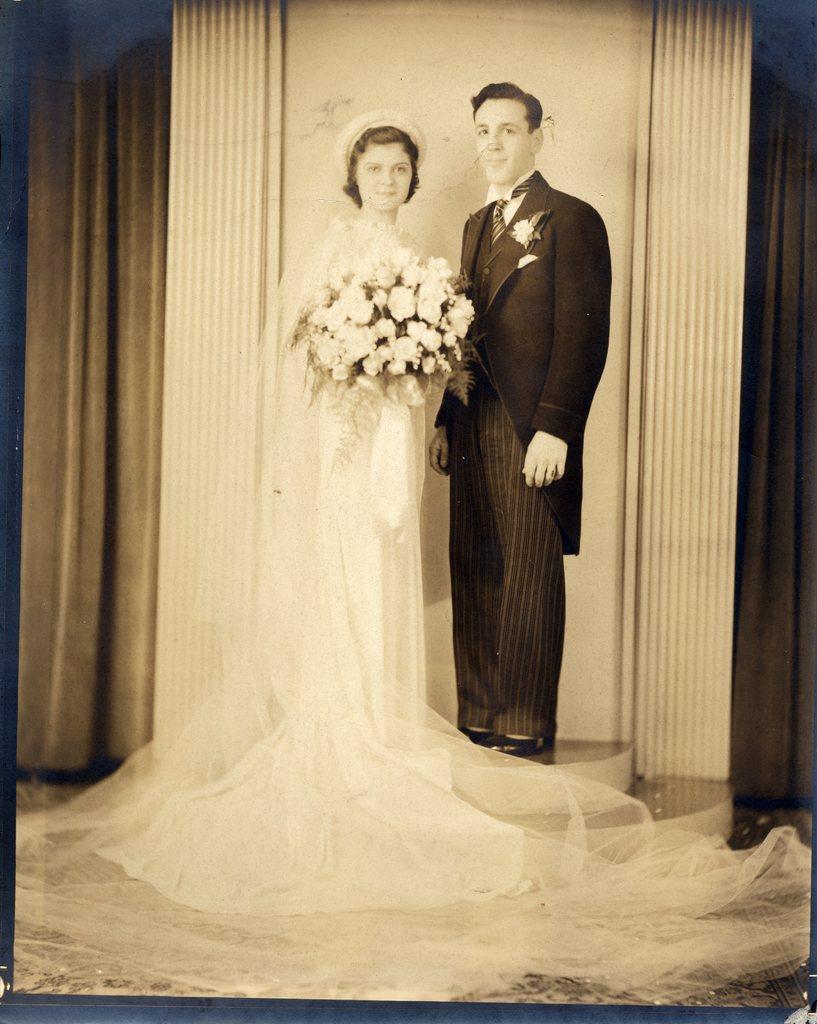Can you describe this image briefly? In this image we can see a black and white picture of two persons. One person is wearing a coat. One woman is holding a group of flowers. In the background, we can see the wall and curtains. 